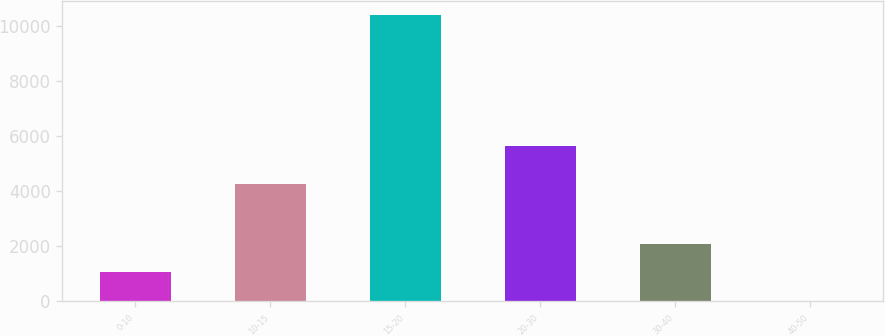Convert chart. <chart><loc_0><loc_0><loc_500><loc_500><bar_chart><fcel>0-10<fcel>10-15<fcel>15-20<fcel>20-30<fcel>30-40<fcel>40-50<nl><fcel>1050<fcel>4258<fcel>10392<fcel>5625<fcel>2088<fcel>12<nl></chart> 